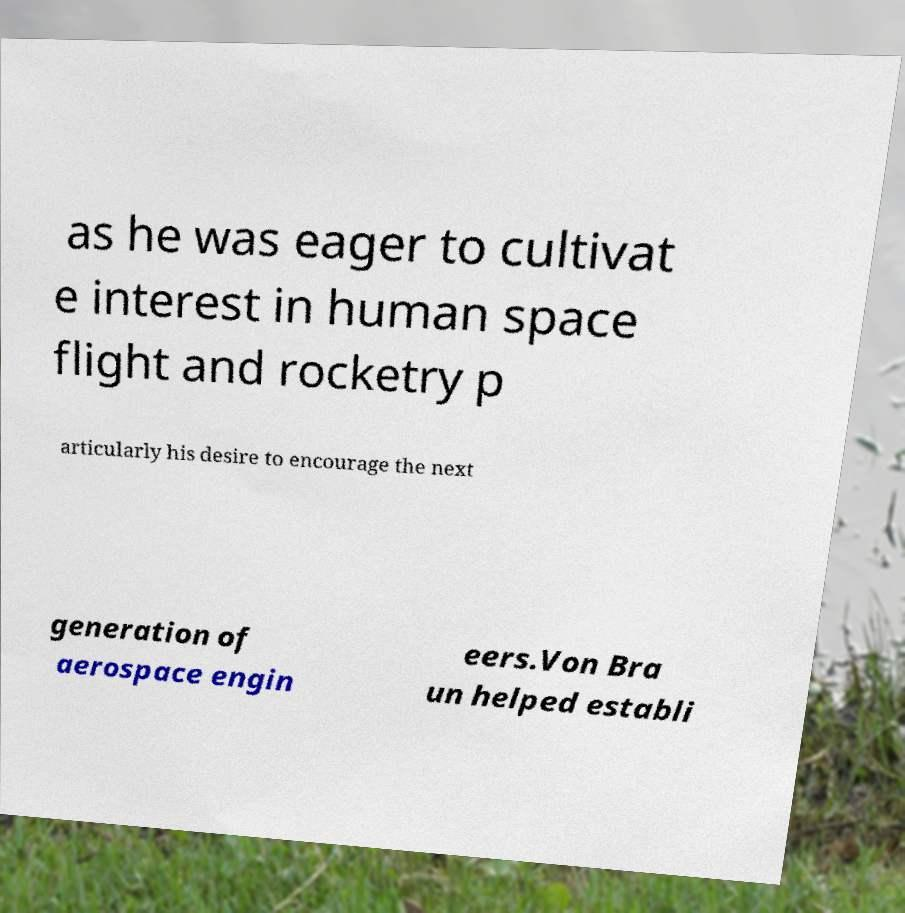There's text embedded in this image that I need extracted. Can you transcribe it verbatim? as he was eager to cultivat e interest in human space flight and rocketry p articularly his desire to encourage the next generation of aerospace engin eers.Von Bra un helped establi 